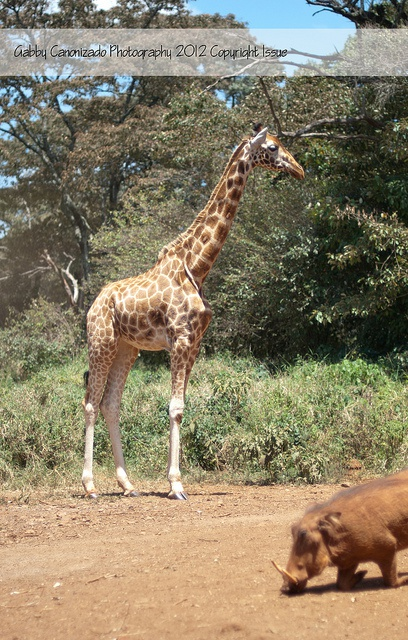Describe the objects in this image and their specific colors. I can see a giraffe in teal, gray, ivory, and tan tones in this image. 